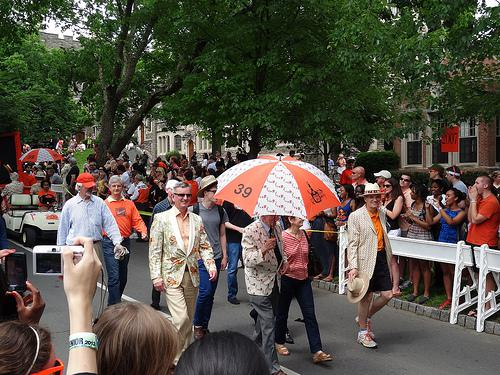Question: why are people gathered?
Choices:
A. To watch a parade.
B. To watch fireworks.
C. To watch a baseball game.
D. To celebrate a graduation.
Answer with the letter. Answer: A Question: what color are the woman's sandals?
Choices:
A. Black.
B. White.
C. Red.
D. Tan.
Answer with the letter. Answer: D Question: how are people behind the walkers traveling?
Choices:
A. On bicycles.
B. In a car.
C. In a golf cart.
D. On segways.
Answer with the letter. Answer: C Question: who is wearing sunglasses in the parade?
Choices:
A. Man in the floral suit.
B. Small child in a stroller.
C. Woman with large brim hat.
D. Police officer.
Answer with the letter. Answer: A 